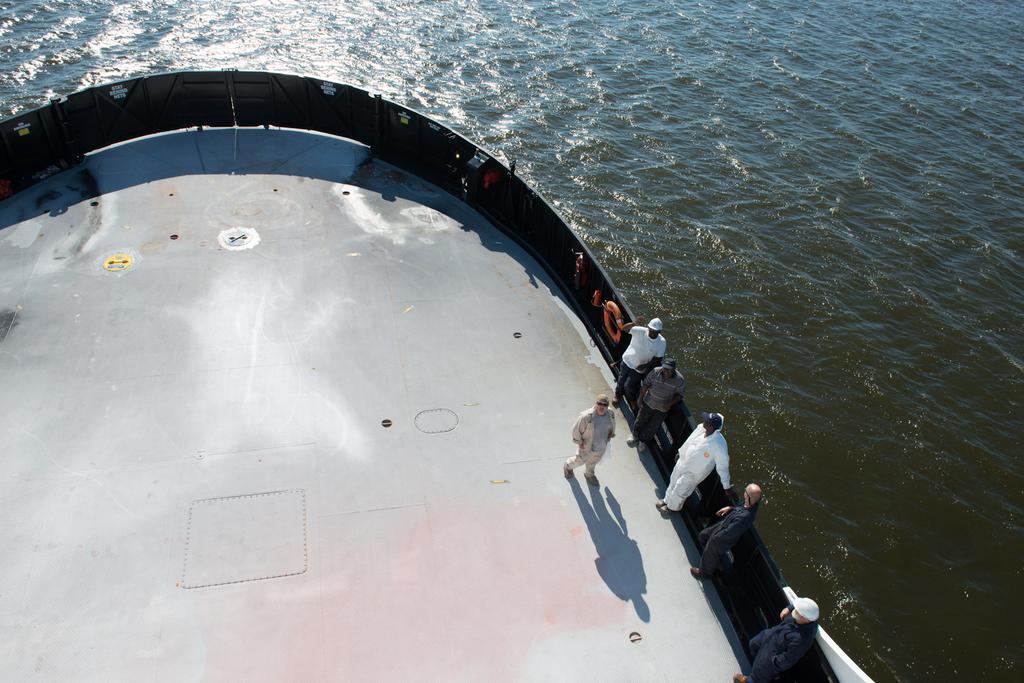Could you give a brief overview of what you see in this image? In this image there are a few people standing in the ship, which is on the river. 